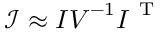Convert formula to latex. <formula><loc_0><loc_0><loc_500><loc_500>\mathcal { I } \approx I V ^ { - 1 } I ^ { T }</formula> 